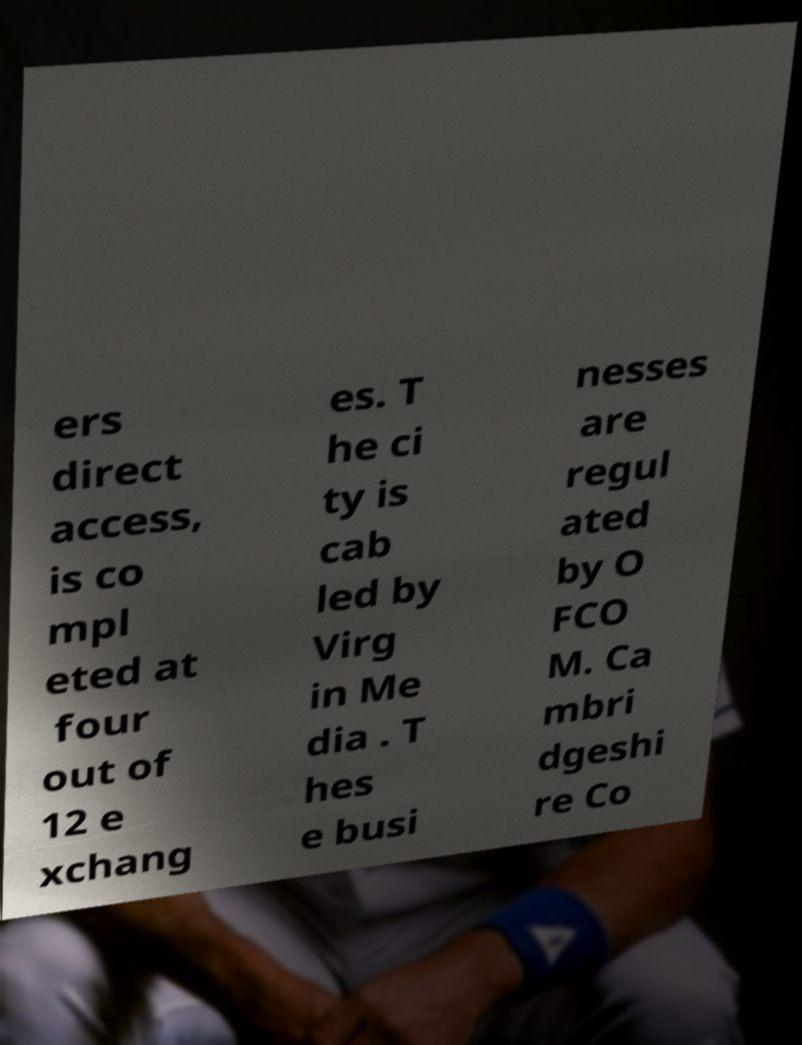Could you extract and type out the text from this image? ers direct access, is co mpl eted at four out of 12 e xchang es. T he ci ty is cab led by Virg in Me dia . T hes e busi nesses are regul ated by O FCO M. Ca mbri dgeshi re Co 